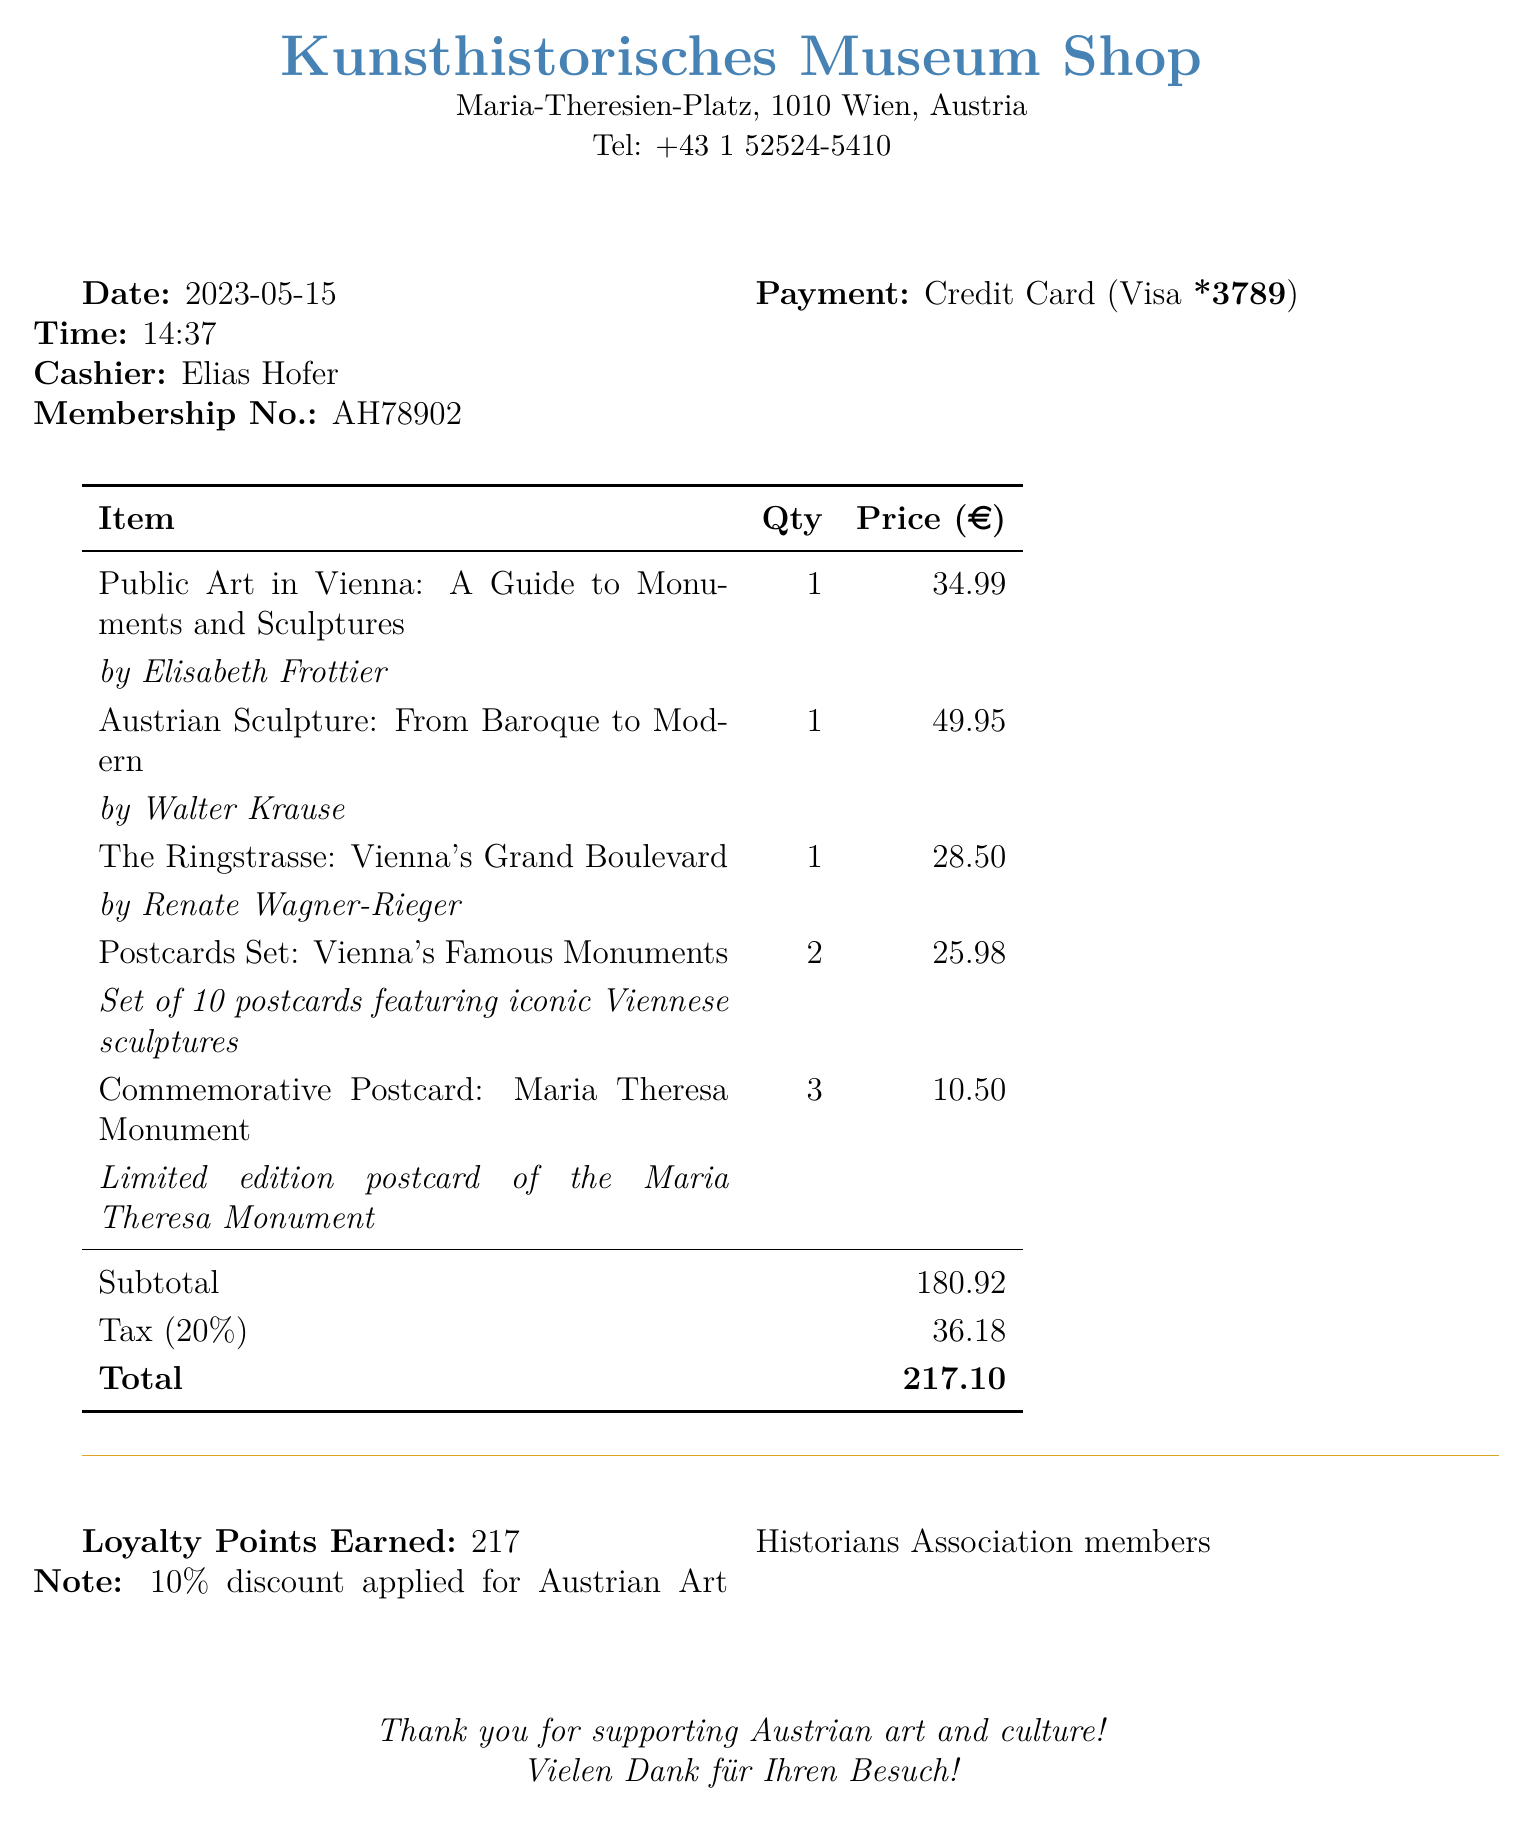What is the store name? The store name is listed at the top of the document.
Answer: Kunsthistorisches Museum Shop What is the date of the purchase? The purchase date is mentioned in the document under the date section.
Answer: 2023-05-15 Who is the author of "Austrian Sculpture: From Baroque to Modern"? The author is detailed in the information provided for that specific item.
Answer: Walter Krause What was the total amount spent? The total amount is provided at the bottom of the receipt.
Answer: 217.10 How many commemorative postcards were purchased? The quantity is listed next to the commemorative postcard item.
Answer: 3 What is the tax rate applied to the purchase? The tax rate is shown in a separate line before the total.
Answer: 20% How many loyalty points were earned? The number of loyalty points earned is mentioned in the loyalty section of the document.
Answer: 217 What discount was applied for members? The note at the bottom specifies the discount for members.
Answer: 10% What payment method was used? The payment method is indicated in the payment information section.
Answer: Credit Card 